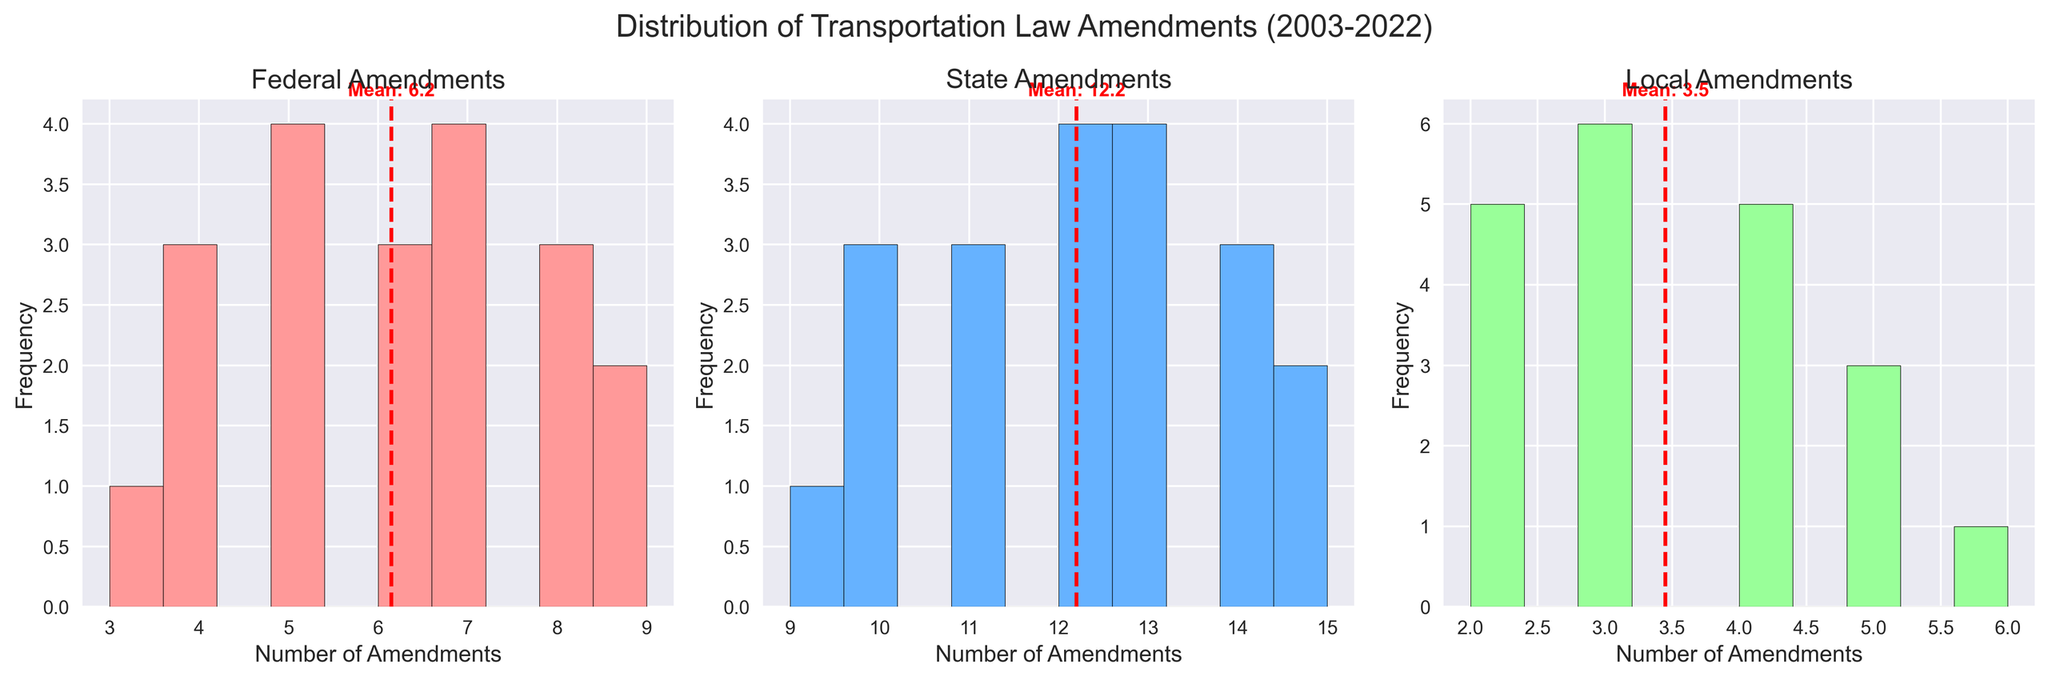What is the title of the figure? The title is located at the top of the figure and summarizes the content being shown. It reads "Distribution of Transportation Law Amendments (2003-2022)".
Answer: Distribution of Transportation Law Amendments (2003-2022) Which category has the highest average of amendments? To determine this, we observe where the mean lines fall on each histogram subplot. The State amendments histogram has the highest average, denoted by the red dashed line's position.
Answer: State How many bins were used in each histogram? Each histogram subplot has intervals for the data grouped into 10 bins, explcitly stated in the code and visible by counting the bars in each histogram.
Answer: 10 Describe the color scheme used for each category's histogram. The Federal histogram bars are pink, the State histogram bars are light blue, and the Local histogram bars are light green. Each histogram also has a red dashed line representing the mean.
Answer: Federal - pink, State - light blue, Local - light green What is the mean number of Local amendments? The red dashed line in the Local amendments histogram represents the mean. By observing the position of this line and the accompanying text, we see the mean is labeled as 3.3.
Answer: 3.3 Which category shows the most frequently occurring amendment count range? Observe each histogram to see which range contains the tallest bars. The State amendments histogram shows the most frequent count in the range of 12-14 amendments, given the highest bars.
Answer: State Between Federal and Local amendments, which category has a higher frequency of 4 amendments? Check the height of the bars corresponding to 4 amendments in both histograms. The Federal amendments histogram shows a taller bar at this count compared to the Local histogram.
Answer: Federal What is the range for the number of State amendments in the histogram? To determine this, we need to identify the smallest and largest amendment counts shown on the x-axis of the State histogram. The range spans from 9 to 15 amendments.
Answer: 9 to 15 Compare the frequency distribution of Federal and State amendments. Which category seems more spread out? Comparing the histograms, the spread of bars in each subplot indicates the distribution. The Federal amendments are more spread out because they range from 3 to 9, while State amendments are tightly clustered between 9 and 15.
Answer: Federal On average, how does the frequency of State amendments compare to Local amendments? By examining the positions of the red dashed mean lines in the State and Local histograms, it is evident that the State amendments have a higher mean value compared to Local amendments.
Answer: State amendments have a higher frequency on average 